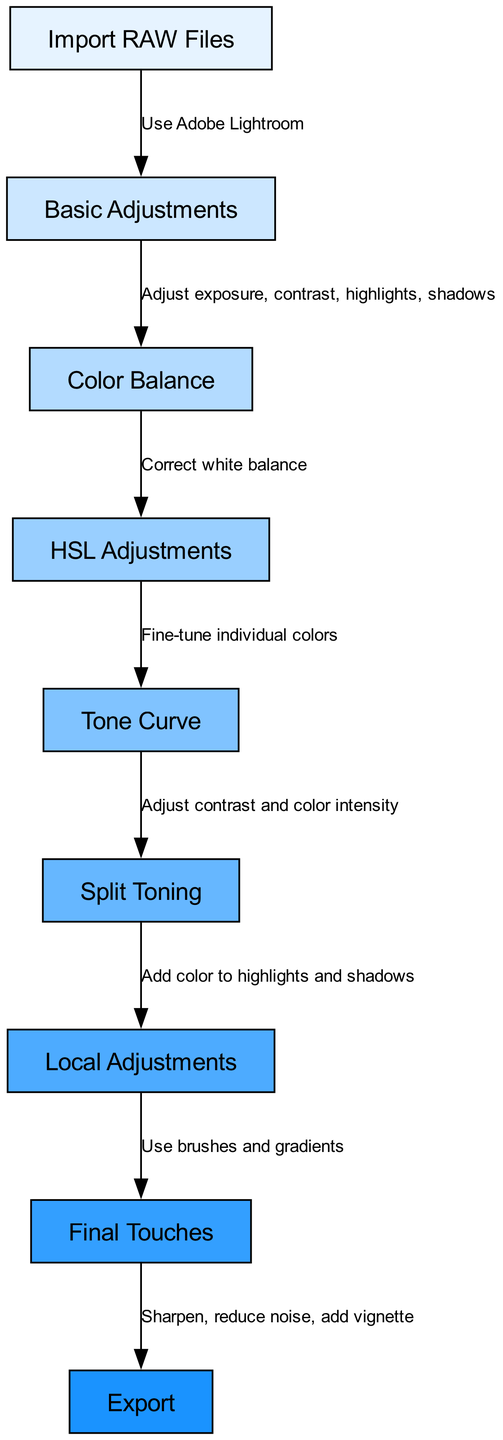What is the total number of nodes in the diagram? The diagram contains nine distinct nodes, as listed in the data under the "nodes" section. Each node represents a step in the workflow for post-production color grading in photography.
Answer: 9 Which node comes after "Basic Adjustments"? The node that follows "Basic Adjustments" is "Color Balance," as indicated by the directed edge in the diagram showing the progression from node 2 to node 3.
Answer: Color Balance What adjustment is made after "HSL Adjustments"? The adjustment made after "HSL Adjustments" is "Tone Curve," which is represented by the directed edge between node 4 and node 5.
Answer: Tone Curve What label describes the relationship between "Import RAW Files" and "Basic Adjustments"? The label that connects these two nodes is "Use Adobe Lightroom," which indicates the software tool needed for that initial step in the workflow.
Answer: Use Adobe Lightroom In the context of this diagram, what process occurs just before "Final Touches"? The process that occurs directly before "Final Touches" is "Local Adjustments," which involves using brushes and gradients as indicated by the directed edge from node 7 to node 8.
Answer: Local Adjustments How many adjustments are made before exporting the image? There are four adjustments made before reaching the "Export" node: "Basic Adjustments," "Color Balance," "HSL Adjustments," and "Tone Curve." Thus, the total is four steps prior to the export.
Answer: 4 What is the function of the "Split Toning" step in the workflow? "Split Toning" serves the function of adding color to highlights and shadows, as indicated by the relationship leading to "Local Adjustments." This role is crucial in refining the image color.
Answer: Add color to highlights and shadows Which step involves adjusting contrast and color intensity? The step responsible for adjusting contrast and color intensity is "Split Toning," as per the edge that connects "Tone Curve" to "Split Toning," indicating a refinement of visual depth and color separation.
Answer: Split Toning What is the final step in the color grading workflow diagram? The final step represented in the workflow is "Export," confirming the completion of the color grading process before the final image is output for use.
Answer: Export 